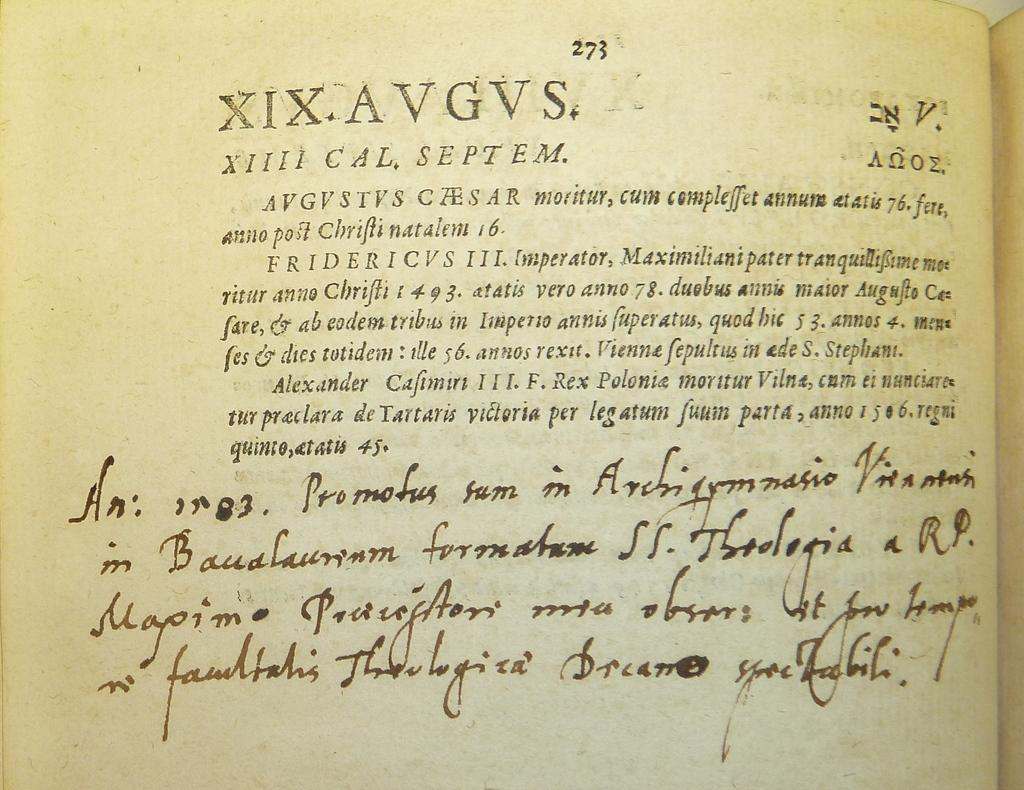Provide a one-sentence caption for the provided image. Book that includes roman numerals and a paragraph with a letter at the bottom. 